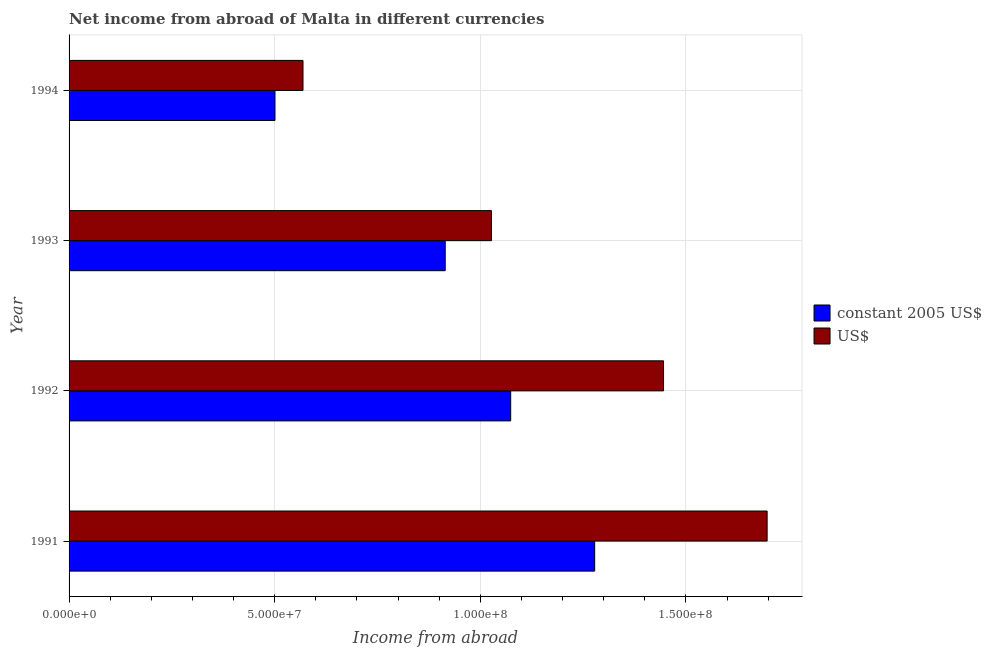How many different coloured bars are there?
Make the answer very short. 2. How many bars are there on the 2nd tick from the bottom?
Provide a succinct answer. 2. What is the label of the 2nd group of bars from the top?
Give a very brief answer. 1993. In how many cases, is the number of bars for a given year not equal to the number of legend labels?
Your answer should be compact. 0. What is the income from abroad in us$ in 1991?
Offer a terse response. 1.70e+08. Across all years, what is the maximum income from abroad in constant 2005 us$?
Your response must be concise. 1.28e+08. Across all years, what is the minimum income from abroad in us$?
Make the answer very short. 5.69e+07. In which year was the income from abroad in us$ maximum?
Make the answer very short. 1991. What is the total income from abroad in constant 2005 us$ in the graph?
Offer a terse response. 3.77e+08. What is the difference between the income from abroad in constant 2005 us$ in 1992 and that in 1994?
Provide a short and direct response. 5.73e+07. What is the difference between the income from abroad in us$ in 1994 and the income from abroad in constant 2005 us$ in 1993?
Give a very brief answer. -3.46e+07. What is the average income from abroad in constant 2005 us$ per year?
Keep it short and to the point. 9.42e+07. In the year 1992, what is the difference between the income from abroad in constant 2005 us$ and income from abroad in us$?
Keep it short and to the point. -3.72e+07. In how many years, is the income from abroad in constant 2005 us$ greater than 100000000 units?
Provide a succinct answer. 2. What is the ratio of the income from abroad in constant 2005 us$ in 1992 to that in 1994?
Give a very brief answer. 2.15. Is the income from abroad in us$ in 1991 less than that in 1993?
Offer a terse response. No. Is the difference between the income from abroad in us$ in 1992 and 1994 greater than the difference between the income from abroad in constant 2005 us$ in 1992 and 1994?
Your response must be concise. Yes. What is the difference between the highest and the second highest income from abroad in us$?
Your answer should be compact. 2.52e+07. What is the difference between the highest and the lowest income from abroad in constant 2005 us$?
Provide a succinct answer. 7.77e+07. In how many years, is the income from abroad in constant 2005 us$ greater than the average income from abroad in constant 2005 us$ taken over all years?
Give a very brief answer. 2. Is the sum of the income from abroad in constant 2005 us$ in 1991 and 1993 greater than the maximum income from abroad in us$ across all years?
Provide a succinct answer. Yes. What does the 1st bar from the top in 1993 represents?
Make the answer very short. US$. What does the 2nd bar from the bottom in 1994 represents?
Your answer should be very brief. US$. How many years are there in the graph?
Your response must be concise. 4. Does the graph contain grids?
Your answer should be very brief. Yes. Where does the legend appear in the graph?
Offer a terse response. Center right. How are the legend labels stacked?
Make the answer very short. Vertical. What is the title of the graph?
Offer a very short reply. Net income from abroad of Malta in different currencies. What is the label or title of the X-axis?
Provide a short and direct response. Income from abroad. What is the Income from abroad of constant 2005 US$ in 1991?
Keep it short and to the point. 1.28e+08. What is the Income from abroad in US$ in 1991?
Your answer should be compact. 1.70e+08. What is the Income from abroad of constant 2005 US$ in 1992?
Your response must be concise. 1.07e+08. What is the Income from abroad of US$ in 1992?
Ensure brevity in your answer.  1.45e+08. What is the Income from abroad of constant 2005 US$ in 1993?
Make the answer very short. 9.15e+07. What is the Income from abroad in US$ in 1993?
Keep it short and to the point. 1.03e+08. What is the Income from abroad in constant 2005 US$ in 1994?
Give a very brief answer. 5.01e+07. What is the Income from abroad of US$ in 1994?
Ensure brevity in your answer.  5.69e+07. Across all years, what is the maximum Income from abroad of constant 2005 US$?
Your answer should be compact. 1.28e+08. Across all years, what is the maximum Income from abroad in US$?
Your answer should be very brief. 1.70e+08. Across all years, what is the minimum Income from abroad of constant 2005 US$?
Give a very brief answer. 5.01e+07. Across all years, what is the minimum Income from abroad of US$?
Ensure brevity in your answer.  5.69e+07. What is the total Income from abroad in constant 2005 US$ in the graph?
Make the answer very short. 3.77e+08. What is the total Income from abroad in US$ in the graph?
Ensure brevity in your answer.  4.74e+08. What is the difference between the Income from abroad of constant 2005 US$ in 1991 and that in 1992?
Make the answer very short. 2.04e+07. What is the difference between the Income from abroad of US$ in 1991 and that in 1992?
Give a very brief answer. 2.52e+07. What is the difference between the Income from abroad in constant 2005 US$ in 1991 and that in 1993?
Provide a short and direct response. 3.63e+07. What is the difference between the Income from abroad of US$ in 1991 and that in 1993?
Give a very brief answer. 6.70e+07. What is the difference between the Income from abroad of constant 2005 US$ in 1991 and that in 1994?
Ensure brevity in your answer.  7.77e+07. What is the difference between the Income from abroad of US$ in 1991 and that in 1994?
Ensure brevity in your answer.  1.13e+08. What is the difference between the Income from abroad in constant 2005 US$ in 1992 and that in 1993?
Offer a terse response. 1.59e+07. What is the difference between the Income from abroad of US$ in 1992 and that in 1993?
Provide a short and direct response. 4.18e+07. What is the difference between the Income from abroad of constant 2005 US$ in 1992 and that in 1994?
Ensure brevity in your answer.  5.73e+07. What is the difference between the Income from abroad of US$ in 1992 and that in 1994?
Make the answer very short. 8.77e+07. What is the difference between the Income from abroad of constant 2005 US$ in 1993 and that in 1994?
Your answer should be compact. 4.14e+07. What is the difference between the Income from abroad in US$ in 1993 and that in 1994?
Give a very brief answer. 4.58e+07. What is the difference between the Income from abroad of constant 2005 US$ in 1991 and the Income from abroad of US$ in 1992?
Offer a very short reply. -1.67e+07. What is the difference between the Income from abroad in constant 2005 US$ in 1991 and the Income from abroad in US$ in 1993?
Make the answer very short. 2.51e+07. What is the difference between the Income from abroad of constant 2005 US$ in 1991 and the Income from abroad of US$ in 1994?
Ensure brevity in your answer.  7.09e+07. What is the difference between the Income from abroad of constant 2005 US$ in 1992 and the Income from abroad of US$ in 1993?
Ensure brevity in your answer.  4.67e+06. What is the difference between the Income from abroad in constant 2005 US$ in 1992 and the Income from abroad in US$ in 1994?
Your response must be concise. 5.05e+07. What is the difference between the Income from abroad in constant 2005 US$ in 1993 and the Income from abroad in US$ in 1994?
Offer a very short reply. 3.46e+07. What is the average Income from abroad in constant 2005 US$ per year?
Give a very brief answer. 9.42e+07. What is the average Income from abroad of US$ per year?
Give a very brief answer. 1.18e+08. In the year 1991, what is the difference between the Income from abroad of constant 2005 US$ and Income from abroad of US$?
Your answer should be compact. -4.19e+07. In the year 1992, what is the difference between the Income from abroad in constant 2005 US$ and Income from abroad in US$?
Offer a very short reply. -3.72e+07. In the year 1993, what is the difference between the Income from abroad of constant 2005 US$ and Income from abroad of US$?
Keep it short and to the point. -1.12e+07. In the year 1994, what is the difference between the Income from abroad of constant 2005 US$ and Income from abroad of US$?
Keep it short and to the point. -6.81e+06. What is the ratio of the Income from abroad in constant 2005 US$ in 1991 to that in 1992?
Provide a short and direct response. 1.19. What is the ratio of the Income from abroad of US$ in 1991 to that in 1992?
Keep it short and to the point. 1.17. What is the ratio of the Income from abroad of constant 2005 US$ in 1991 to that in 1993?
Your answer should be compact. 1.4. What is the ratio of the Income from abroad in US$ in 1991 to that in 1993?
Ensure brevity in your answer.  1.65. What is the ratio of the Income from abroad in constant 2005 US$ in 1991 to that in 1994?
Ensure brevity in your answer.  2.55. What is the ratio of the Income from abroad in US$ in 1991 to that in 1994?
Provide a succinct answer. 2.98. What is the ratio of the Income from abroad of constant 2005 US$ in 1992 to that in 1993?
Offer a very short reply. 1.17. What is the ratio of the Income from abroad of US$ in 1992 to that in 1993?
Offer a terse response. 1.41. What is the ratio of the Income from abroad of constant 2005 US$ in 1992 to that in 1994?
Your response must be concise. 2.14. What is the ratio of the Income from abroad in US$ in 1992 to that in 1994?
Ensure brevity in your answer.  2.54. What is the ratio of the Income from abroad of constant 2005 US$ in 1993 to that in 1994?
Give a very brief answer. 1.83. What is the ratio of the Income from abroad in US$ in 1993 to that in 1994?
Provide a succinct answer. 1.81. What is the difference between the highest and the second highest Income from abroad of constant 2005 US$?
Your response must be concise. 2.04e+07. What is the difference between the highest and the second highest Income from abroad in US$?
Make the answer very short. 2.52e+07. What is the difference between the highest and the lowest Income from abroad of constant 2005 US$?
Provide a short and direct response. 7.77e+07. What is the difference between the highest and the lowest Income from abroad of US$?
Make the answer very short. 1.13e+08. 